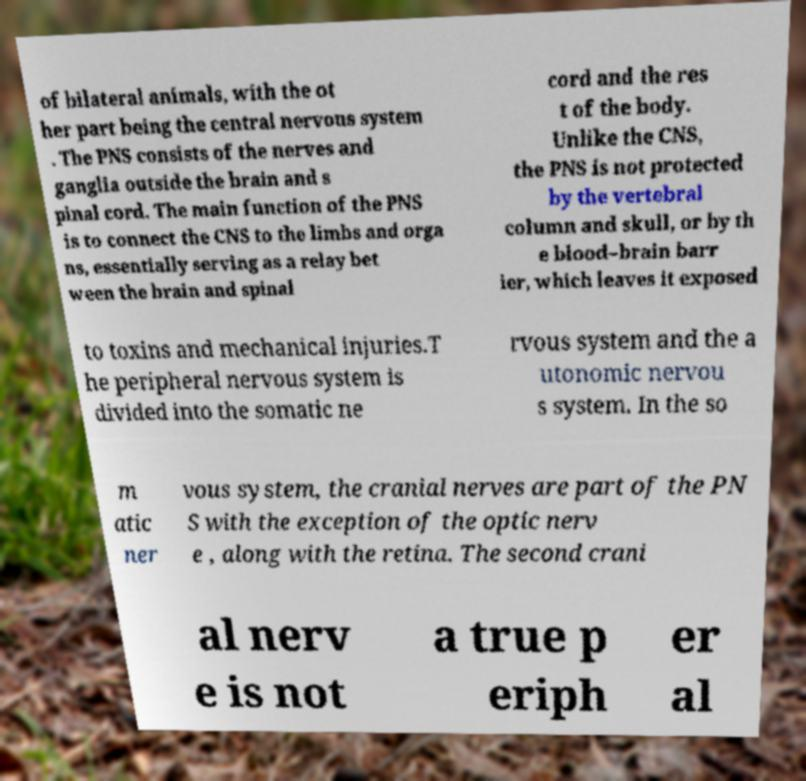Can you read and provide the text displayed in the image?This photo seems to have some interesting text. Can you extract and type it out for me? of bilateral animals, with the ot her part being the central nervous system . The PNS consists of the nerves and ganglia outside the brain and s pinal cord. The main function of the PNS is to connect the CNS to the limbs and orga ns, essentially serving as a relay bet ween the brain and spinal cord and the res t of the body. Unlike the CNS, the PNS is not protected by the vertebral column and skull, or by th e blood–brain barr ier, which leaves it exposed to toxins and mechanical injuries.T he peripheral nervous system is divided into the somatic ne rvous system and the a utonomic nervou s system. In the so m atic ner vous system, the cranial nerves are part of the PN S with the exception of the optic nerv e , along with the retina. The second crani al nerv e is not a true p eriph er al 